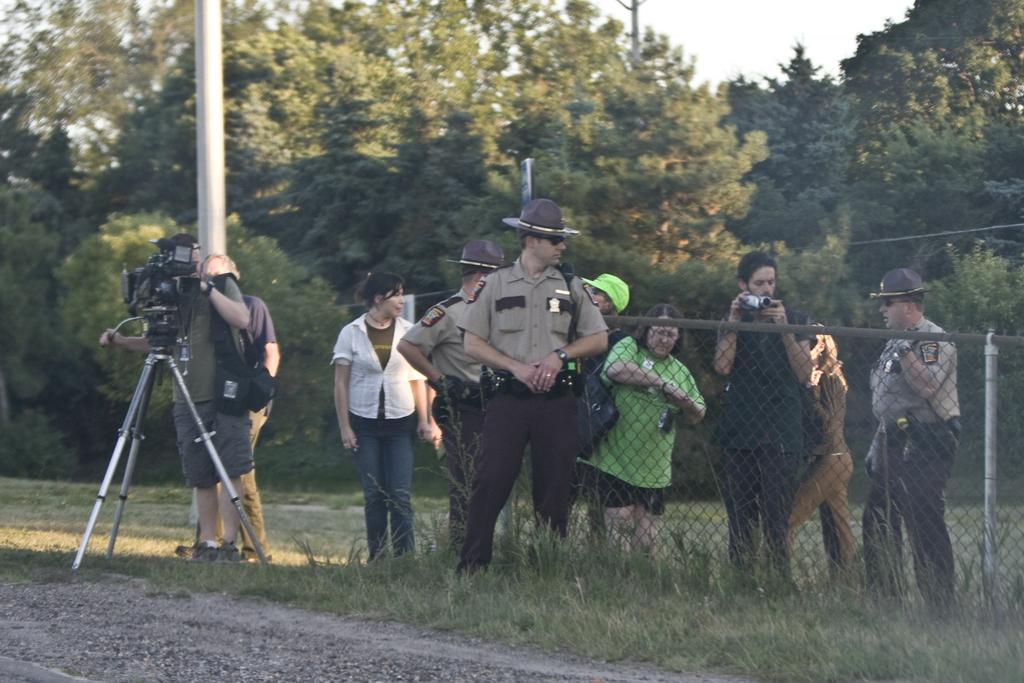What are the people in the image doing? The people in the image are standing on the grass. Can you describe what one of the people is holding? One of the people is holding a camera. What can be seen in the background of the image? There are trees and the sky visible in the background of the image. Can you tell me how many cobwebs are visible in the image? There are no cobwebs visible in the image. What type of dog can be seen playing with the people in the image? There are no dogs present in the image. 